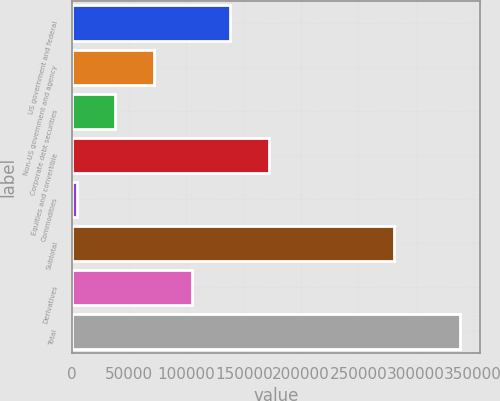<chart> <loc_0><loc_0><loc_500><loc_500><bar_chart><fcel>US government and federal<fcel>Non-US government and agency<fcel>Corporate debt securities<fcel>Equities and convertible<fcel>Commodities<fcel>Subtotal<fcel>Derivatives<fcel>Total<nl><fcel>138382<fcel>71469<fcel>38012.5<fcel>171838<fcel>4556<fcel>281242<fcel>104926<fcel>339121<nl></chart> 